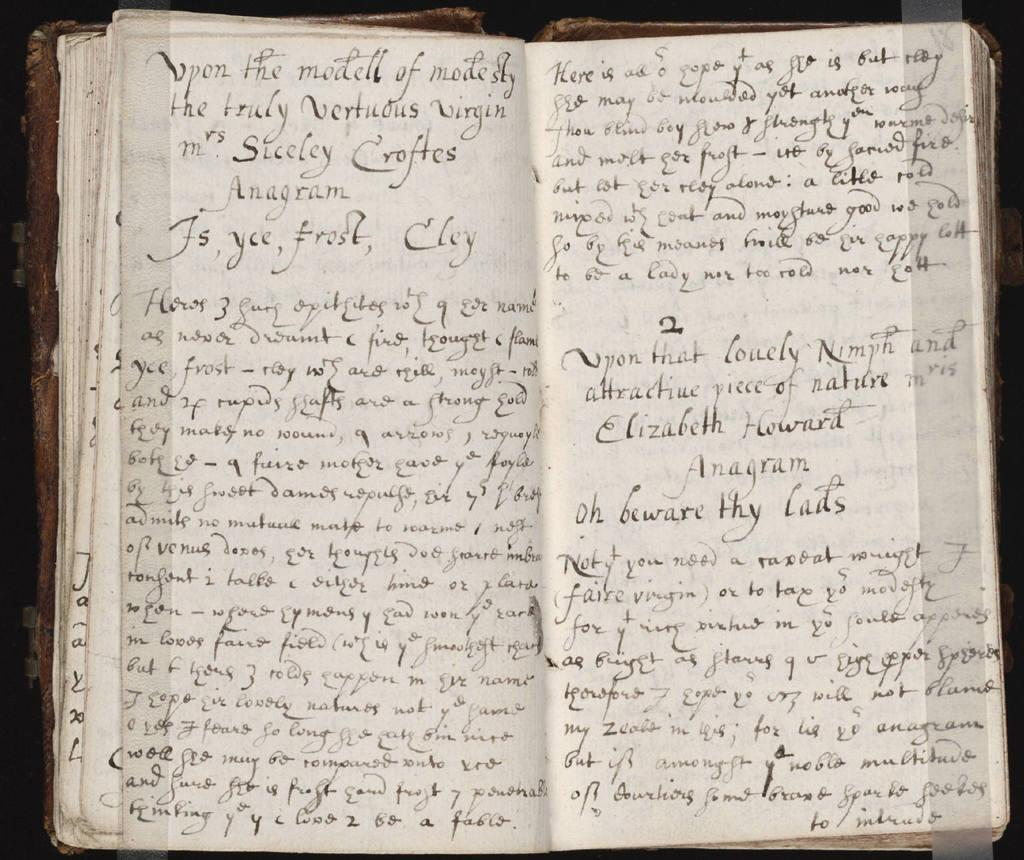What is present in the foreground of the image? The book is in the foreground of the image. What can be seen on the book? There is text on the book in the image. How many grapes are on the donkey in the image? There is no donkey or grapes present in the image; it only features a book with text on its cover. 